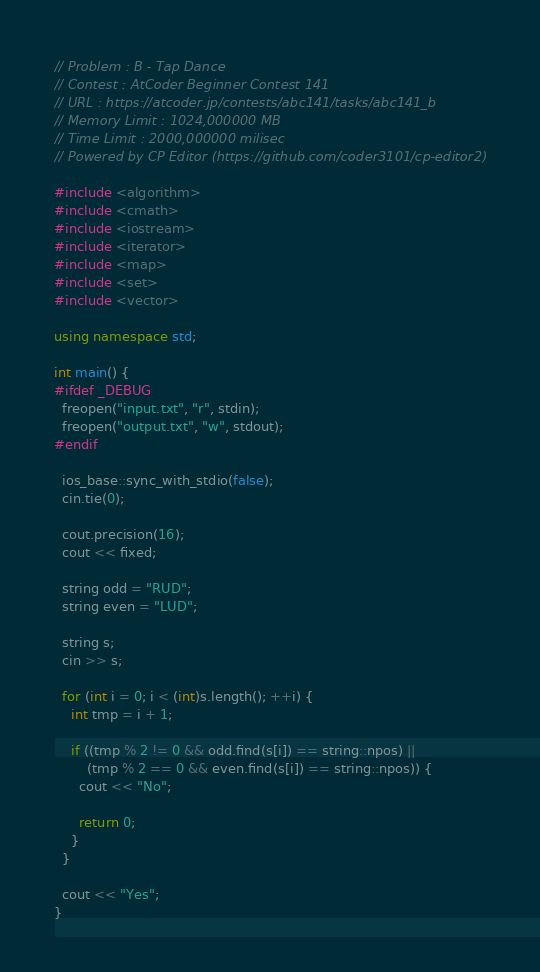Convert code to text. <code><loc_0><loc_0><loc_500><loc_500><_C++_>
// Problem : B - Tap Dance
// Contest : AtCoder Beginner Contest 141
// URL : https://atcoder.jp/contests/abc141/tasks/abc141_b
// Memory Limit : 1024,000000 MB 
// Time Limit : 2000,000000 milisec 
// Powered by CP Editor (https://github.com/coder3101/cp-editor2)

#include <algorithm>
#include <cmath>
#include <iostream>
#include <iterator>
#include <map>
#include <set>
#include <vector>

using namespace std;

int main() {
#ifdef _DEBUG
  freopen("input.txt", "r", stdin);
  freopen("output.txt", "w", stdout);
#endif

  ios_base::sync_with_stdio(false);
  cin.tie(0);

  cout.precision(16);
  cout << fixed;
  
  string odd = "RUD";
  string even = "LUD";
  
  string s;
  cin >> s;
  
  for (int i = 0; i < (int)s.length(); ++i) {
    int tmp = i + 1;
    
    if ((tmp % 2 != 0 && odd.find(s[i]) == string::npos) ||
        (tmp % 2 == 0 && even.find(s[i]) == string::npos)) {
      cout << "No";
      
      return 0;
    }
  }
  
  cout << "Yes";
}
</code> 